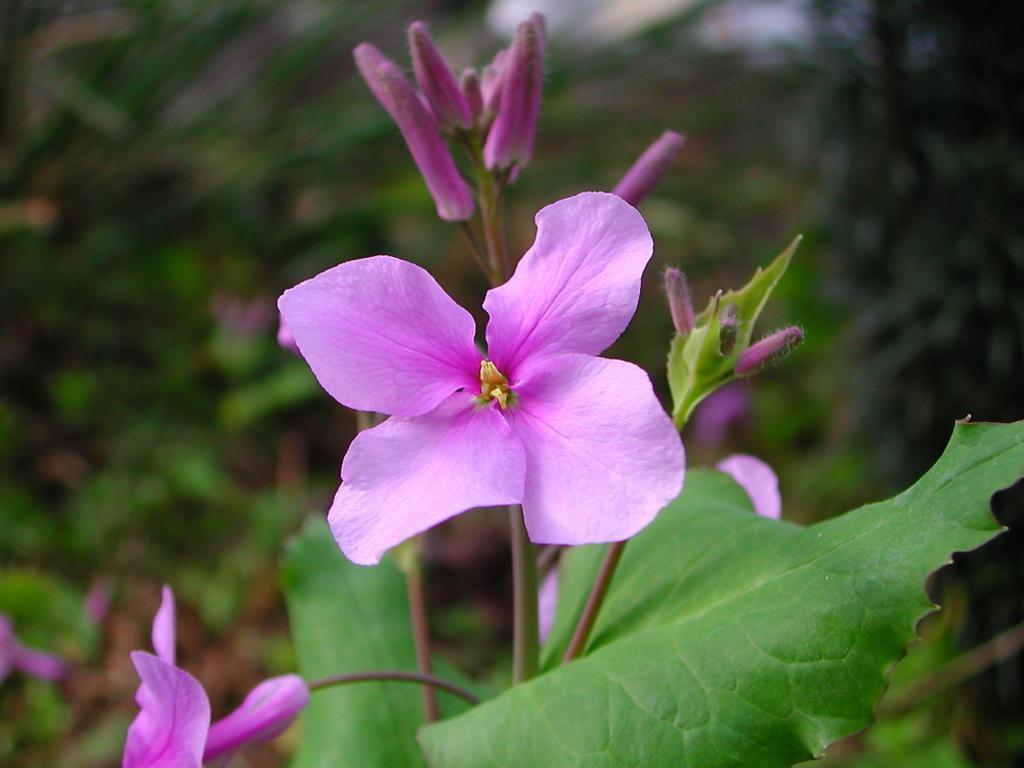Please provide a concise description of this image. As we can see in the image in the front there is a plant and flower. The background is blurred. 